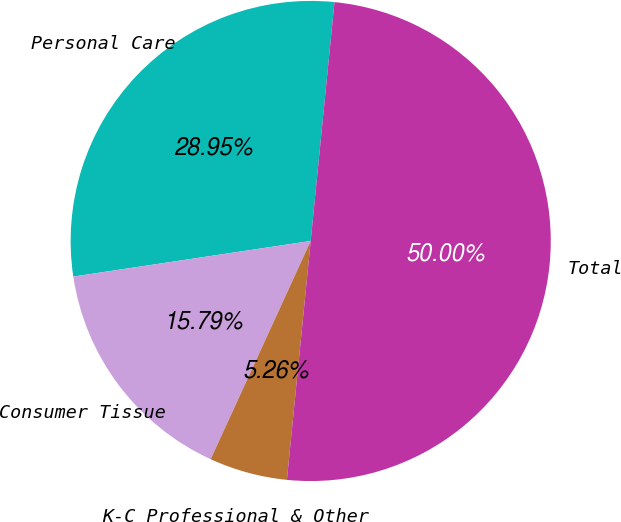Convert chart to OTSL. <chart><loc_0><loc_0><loc_500><loc_500><pie_chart><fcel>Personal Care<fcel>Consumer Tissue<fcel>K-C Professional & Other<fcel>Total<nl><fcel>28.95%<fcel>15.79%<fcel>5.26%<fcel>50.0%<nl></chart> 